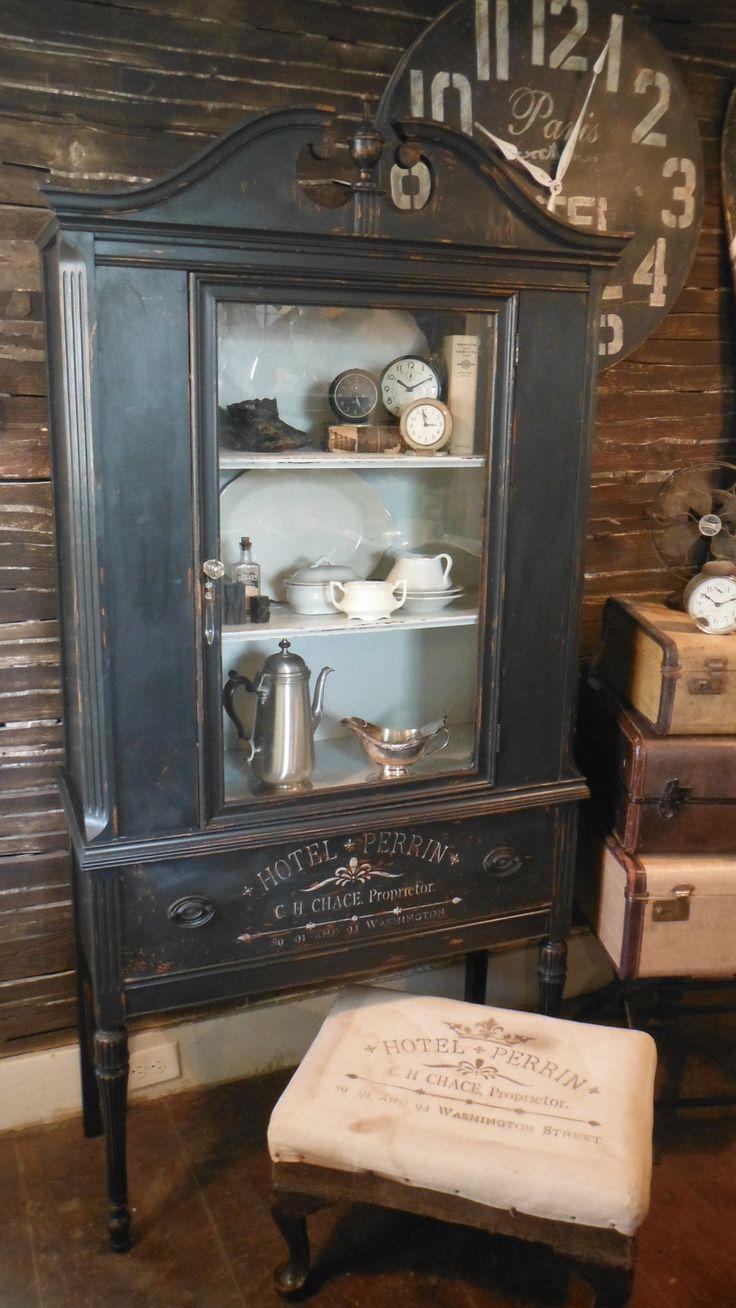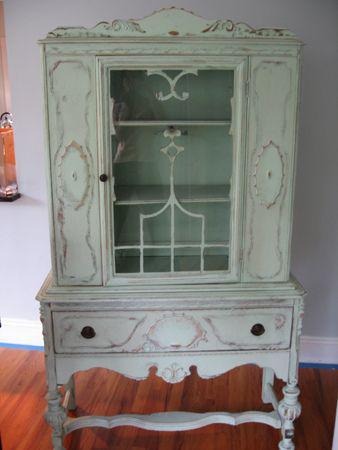The first image is the image on the left, the second image is the image on the right. Considering the images on both sides, is "One hutch has a horizontal spindle between the front legs, below a full-width drawer." valid? Answer yes or no. Yes. 